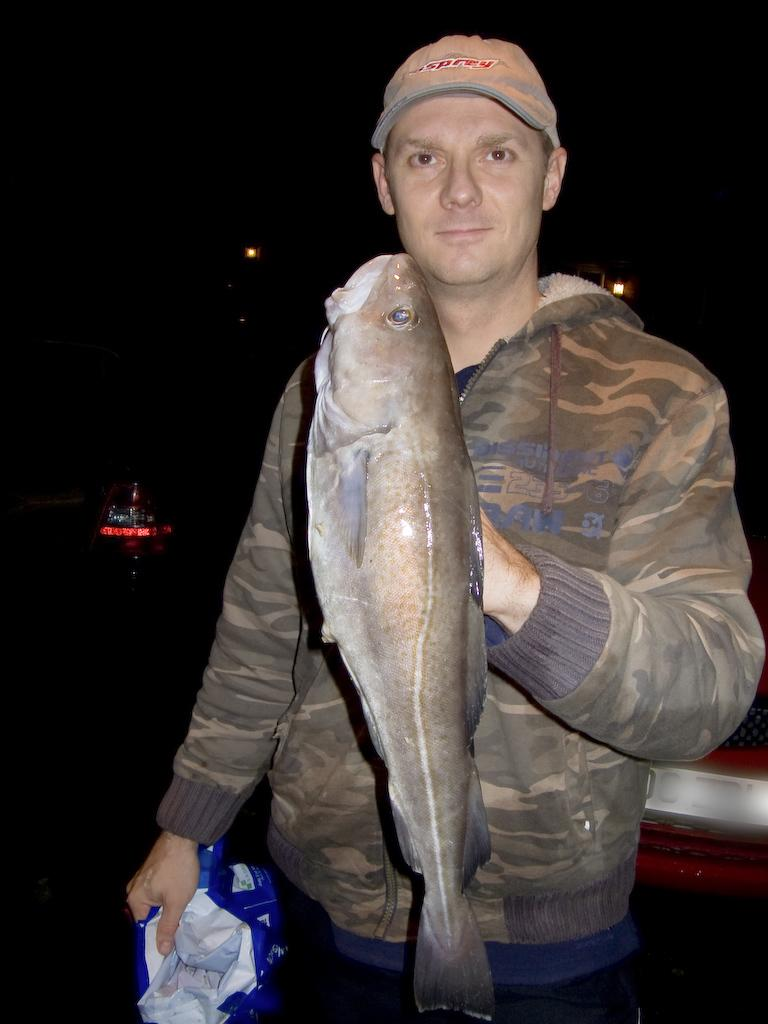What is the main subject of the image? The main subject of the image is a man. What is the man wearing on his upper body? The man is wearing a jacket. What is the man wearing on his head? The man is wearing a cap on his head. What is the man holding in his hands? The man is holding a fish and another object. What is the man doing in the image? The man is posing for the picture. What is the color of the background in the image? The background of the image is black. What type of bone can be seen sticking out of the bushes in the image? There are no bones or bushes present in the image; it features a man holding a fish and another object against a black background. 